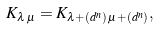Convert formula to latex. <formula><loc_0><loc_0><loc_500><loc_500>K _ { \lambda \, \mu } = K _ { \lambda + ( d ^ { n } ) \, \mu + ( d ^ { n } ) } ,</formula> 